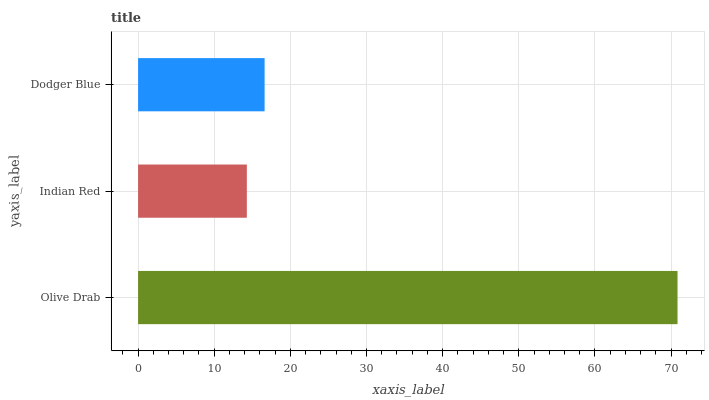Is Indian Red the minimum?
Answer yes or no. Yes. Is Olive Drab the maximum?
Answer yes or no. Yes. Is Dodger Blue the minimum?
Answer yes or no. No. Is Dodger Blue the maximum?
Answer yes or no. No. Is Dodger Blue greater than Indian Red?
Answer yes or no. Yes. Is Indian Red less than Dodger Blue?
Answer yes or no. Yes. Is Indian Red greater than Dodger Blue?
Answer yes or no. No. Is Dodger Blue less than Indian Red?
Answer yes or no. No. Is Dodger Blue the high median?
Answer yes or no. Yes. Is Dodger Blue the low median?
Answer yes or no. Yes. Is Olive Drab the high median?
Answer yes or no. No. Is Olive Drab the low median?
Answer yes or no. No. 